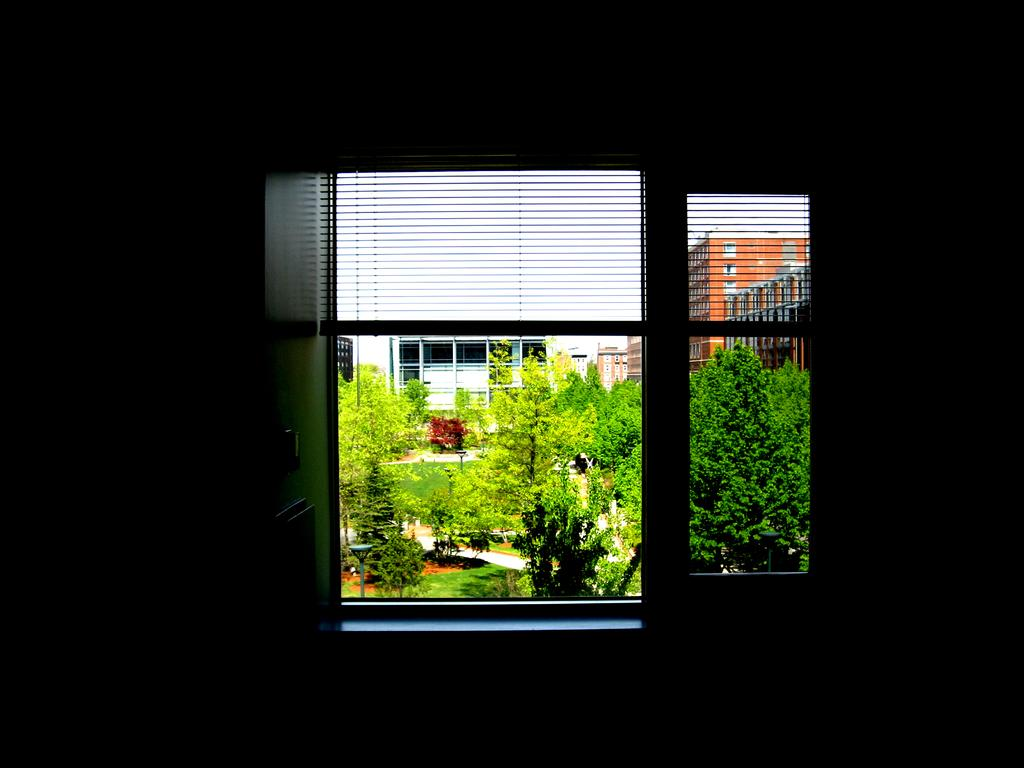What type of natural elements can be seen in the image? There are trees in the image. What type of man-made structures are present in the image? There are buildings in the image. What feature is common to both trees and buildings in the image? There are windows in the image. Can you describe the window that is closest to the viewer in the image? There is a window visible in the foreground of the image. What type of sticks can be seen in the image? There are no sticks present in the image. How many pies are visible in the image? There are no pies present in the image. 